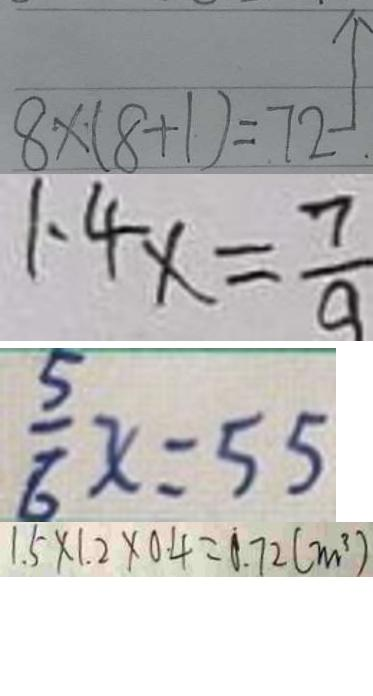Convert formula to latex. <formula><loc_0><loc_0><loc_500><loc_500>8 \times ( 8 + 1 ) = 7 2 
 1 . 4 x = \frac { 7 } { 9 } 
 \frac { 5 } { 6 } x = 5 5 
 1 . 5 \times 1 . 2 \times 0 . 4 = 0 . 7 2 ( m ^ { 3 } )</formula> 